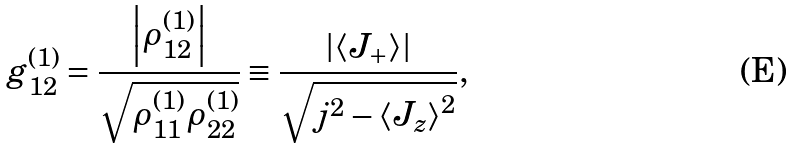Convert formula to latex. <formula><loc_0><loc_0><loc_500><loc_500>g _ { 1 2 } ^ { ( 1 ) } = \frac { \left | \rho _ { 1 2 } ^ { ( 1 ) } \right | } { \sqrt { \rho _ { 1 1 } ^ { ( 1 ) } \rho _ { 2 2 } ^ { ( 1 ) } } } \equiv \frac { \left | \left \langle J _ { + } \right \rangle \right | } { \sqrt { j ^ { 2 } - \left \langle J _ { z } \right \rangle ^ { 2 } } } ,</formula> 